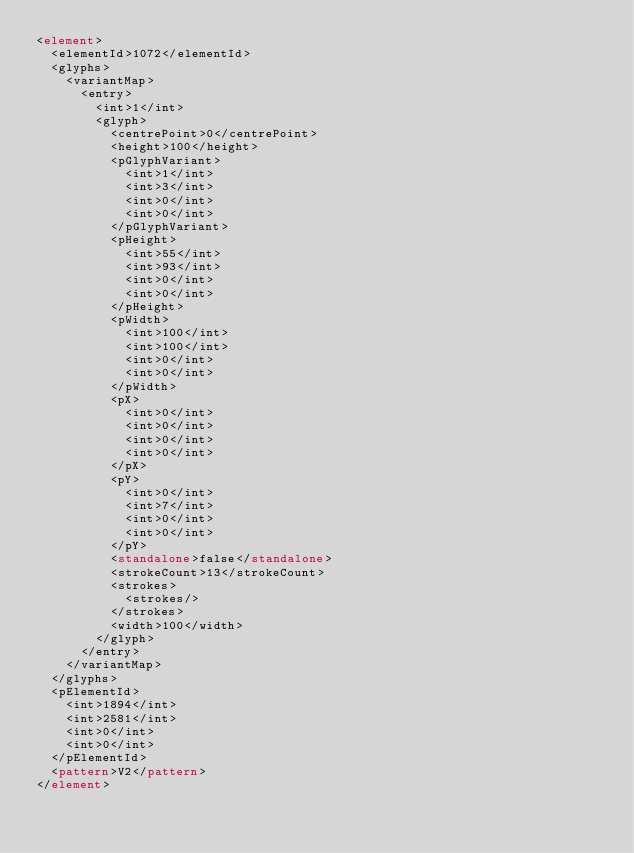<code> <loc_0><loc_0><loc_500><loc_500><_XML_><element>
  <elementId>1072</elementId>
  <glyphs>
    <variantMap>
      <entry>
        <int>1</int>
        <glyph>
          <centrePoint>0</centrePoint>
          <height>100</height>
          <pGlyphVariant>
            <int>1</int>
            <int>3</int>
            <int>0</int>
            <int>0</int>
          </pGlyphVariant>
          <pHeight>
            <int>55</int>
            <int>93</int>
            <int>0</int>
            <int>0</int>
          </pHeight>
          <pWidth>
            <int>100</int>
            <int>100</int>
            <int>0</int>
            <int>0</int>
          </pWidth>
          <pX>
            <int>0</int>
            <int>0</int>
            <int>0</int>
            <int>0</int>
          </pX>
          <pY>
            <int>0</int>
            <int>7</int>
            <int>0</int>
            <int>0</int>
          </pY>
          <standalone>false</standalone>
          <strokeCount>13</strokeCount>
          <strokes>
            <strokes/>
          </strokes>
          <width>100</width>
        </glyph>
      </entry>
    </variantMap>
  </glyphs>
  <pElementId>
    <int>1894</int>
    <int>2581</int>
    <int>0</int>
    <int>0</int>
  </pElementId>
  <pattern>V2</pattern>
</element></code> 